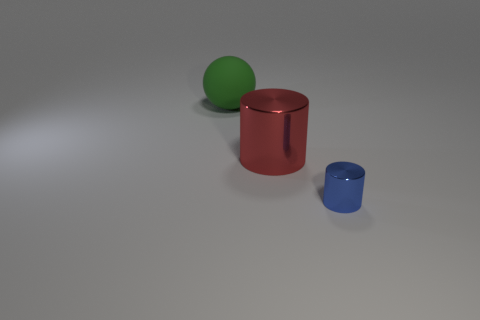Add 2 tiny red rubber spheres. How many objects exist? 5 Subtract all cylinders. How many objects are left? 1 Add 3 shiny cylinders. How many shiny cylinders are left? 5 Add 2 green metal blocks. How many green metal blocks exist? 2 Subtract 0 green blocks. How many objects are left? 3 Subtract all spheres. Subtract all tiny things. How many objects are left? 1 